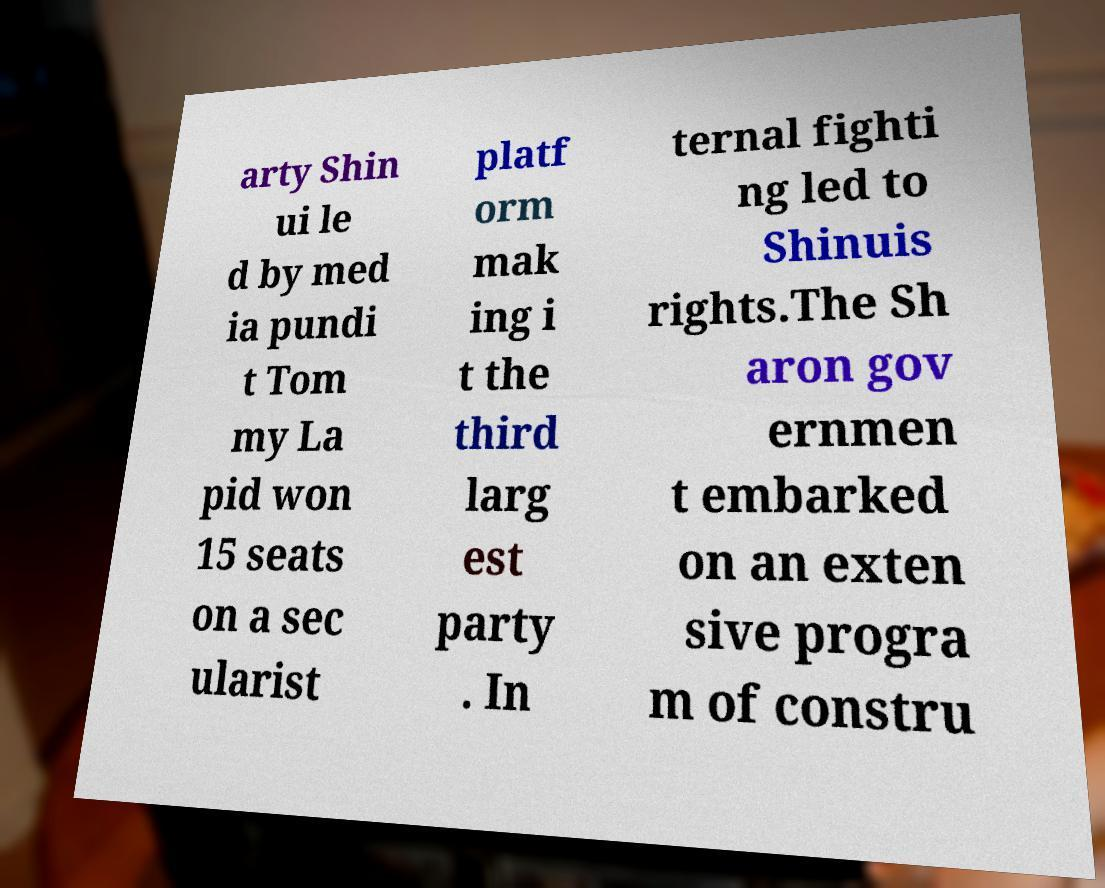Could you assist in decoding the text presented in this image and type it out clearly? arty Shin ui le d by med ia pundi t Tom my La pid won 15 seats on a sec ularist platf orm mak ing i t the third larg est party . In ternal fighti ng led to Shinuis rights.The Sh aron gov ernmen t embarked on an exten sive progra m of constru 